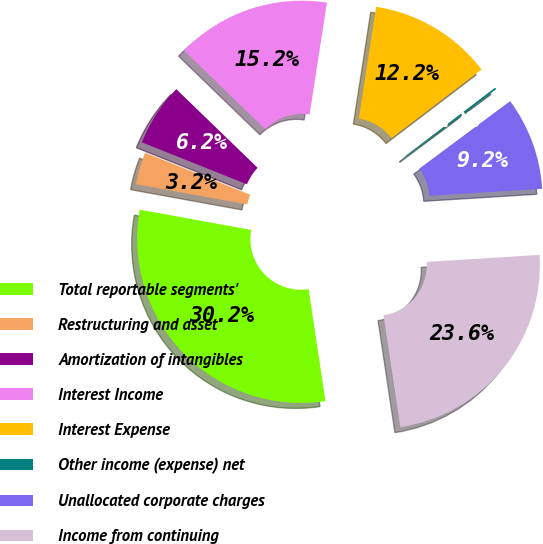Convert chart to OTSL. <chart><loc_0><loc_0><loc_500><loc_500><pie_chart><fcel>Total reportable segments'<fcel>Restructuring and asset<fcel>Amortization of intangibles<fcel>Interest Income<fcel>Interest Expense<fcel>Other income (expense) net<fcel>Unallocated corporate charges<fcel>Income from continuing<nl><fcel>30.24%<fcel>3.18%<fcel>6.19%<fcel>15.21%<fcel>12.2%<fcel>0.18%<fcel>9.19%<fcel>23.61%<nl></chart> 